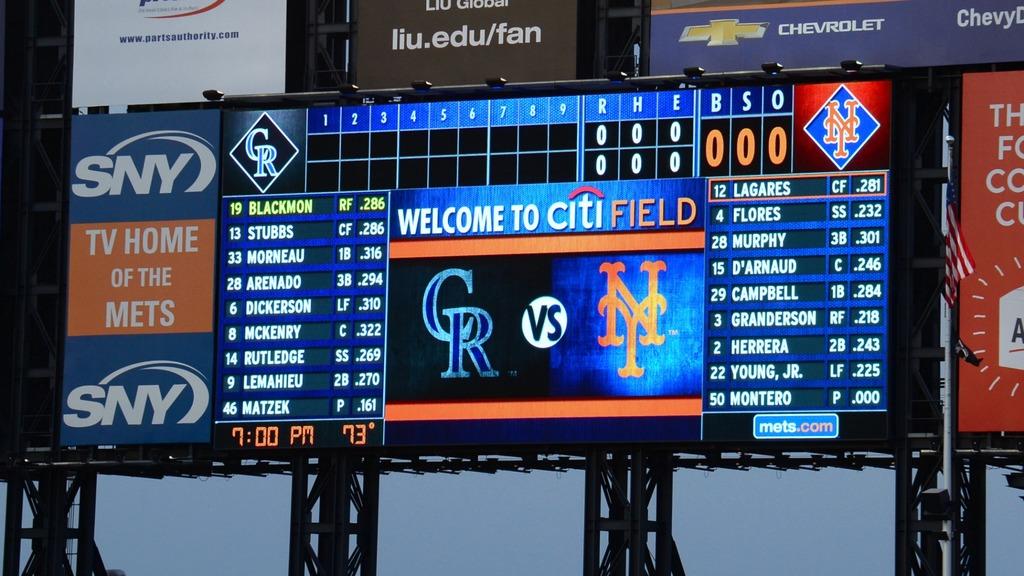Welcome to where?
Offer a terse response. Citi field. Whats the name of this field?
Your answer should be very brief. Citifield. 